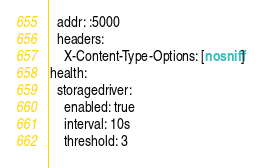Convert code to text. <code><loc_0><loc_0><loc_500><loc_500><_YAML_>  addr: :5000
  headers:
    X-Content-Type-Options: [nosniff]
health:
  storagedriver:
    enabled: true
    interval: 10s
    threshold: 3
</code> 